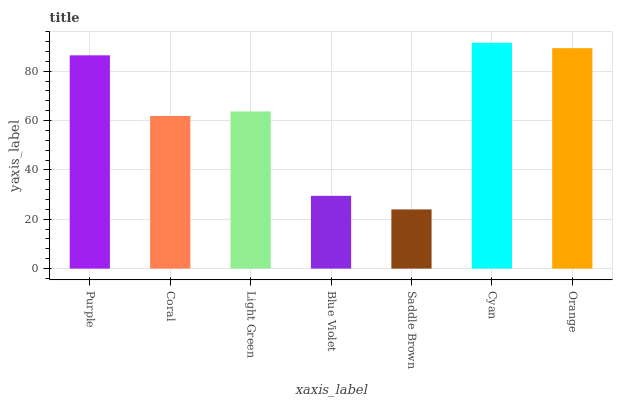Is Saddle Brown the minimum?
Answer yes or no. Yes. Is Cyan the maximum?
Answer yes or no. Yes. Is Coral the minimum?
Answer yes or no. No. Is Coral the maximum?
Answer yes or no. No. Is Purple greater than Coral?
Answer yes or no. Yes. Is Coral less than Purple?
Answer yes or no. Yes. Is Coral greater than Purple?
Answer yes or no. No. Is Purple less than Coral?
Answer yes or no. No. Is Light Green the high median?
Answer yes or no. Yes. Is Light Green the low median?
Answer yes or no. Yes. Is Orange the high median?
Answer yes or no. No. Is Purple the low median?
Answer yes or no. No. 